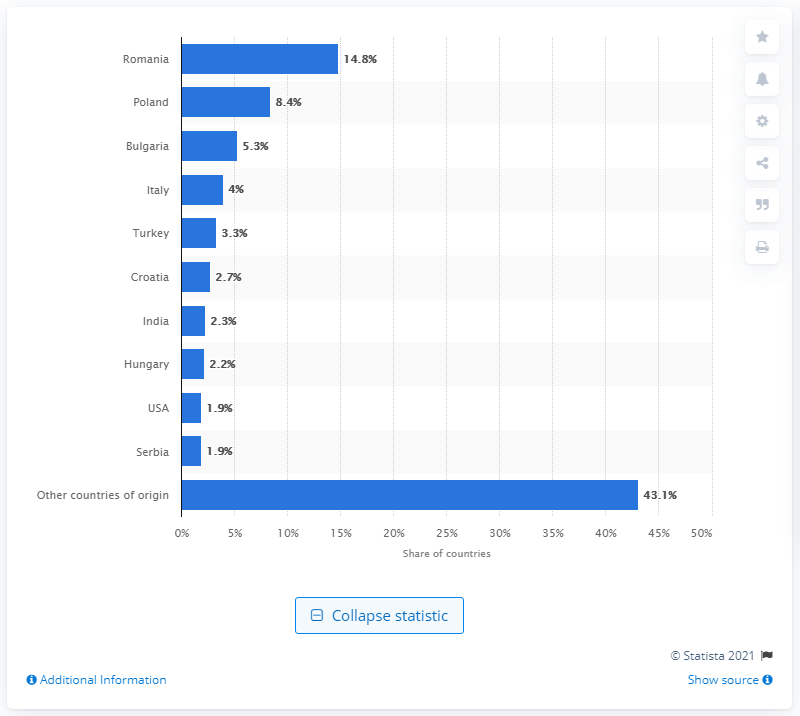Highlight a few significant elements in this photo. In 2019, Poland was the country with the eighth-largest share among countries of origin for immigrants living in Germany, with an 8.4% share. 